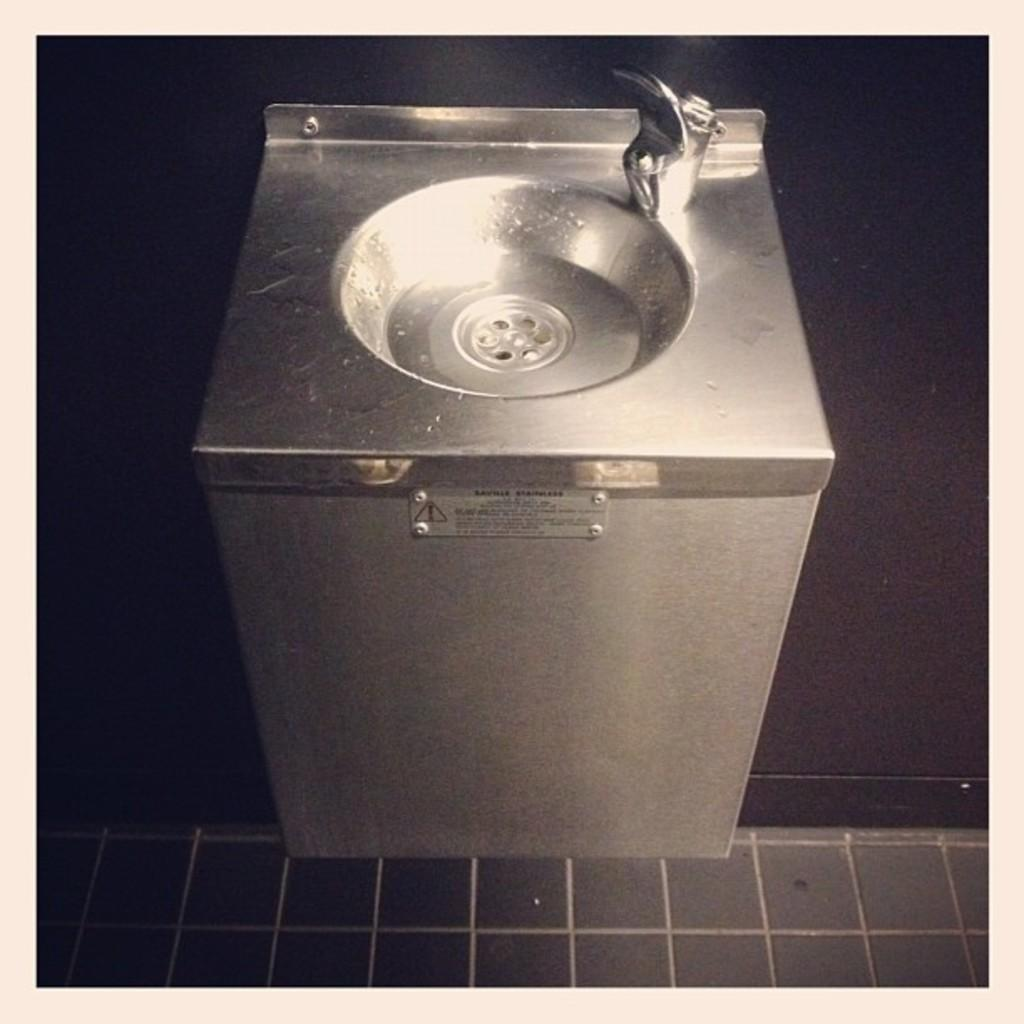What is the main object in the image? There is a bathroom sink in the image. How is the sink connected to the surrounding area? The sink is attached to a surface. What type of flooring is visible below the sink? There are tiles below the sink. What type of art is hanging on the wall in the bedroom in the image? There is no bedroom or art present in the image; it features a bathroom sink with tiles below it. 